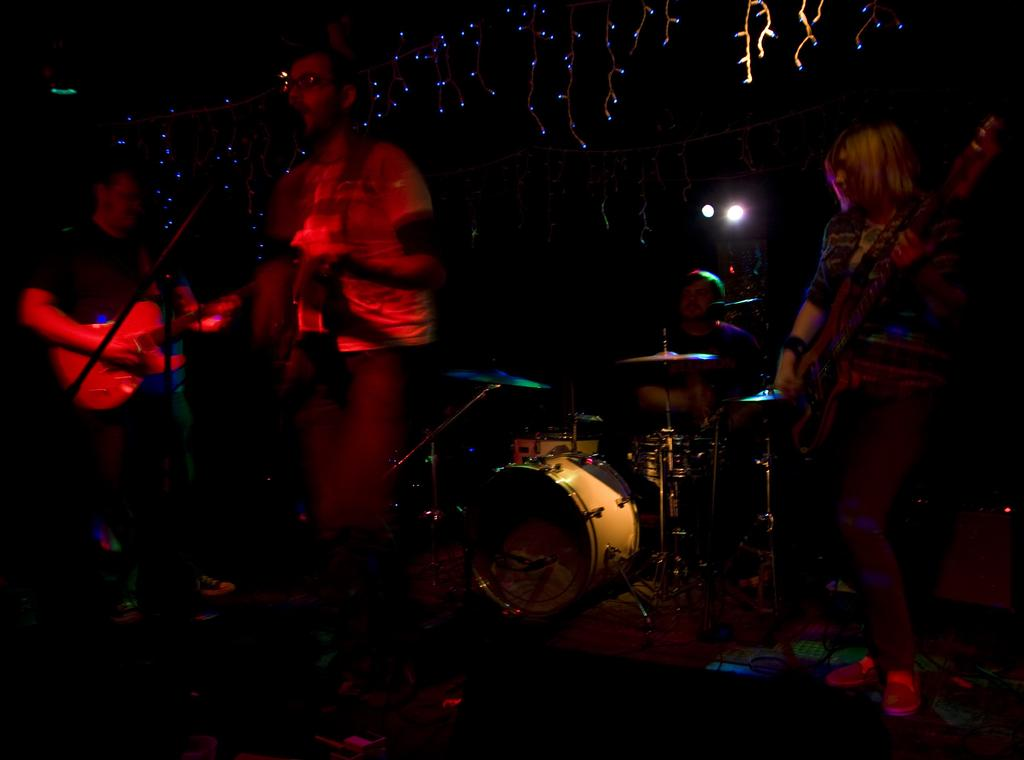What is happening in the image? There is a band performing on a stage. How many members of the band are playing guitar? Three members of the band are playing guitar. What instrument is the fourth member of the band playing? One member of the band is playing drums. What type of quiver can be seen on the stage during the band's performance? There is no quiver present on the stage during the band's performance. 